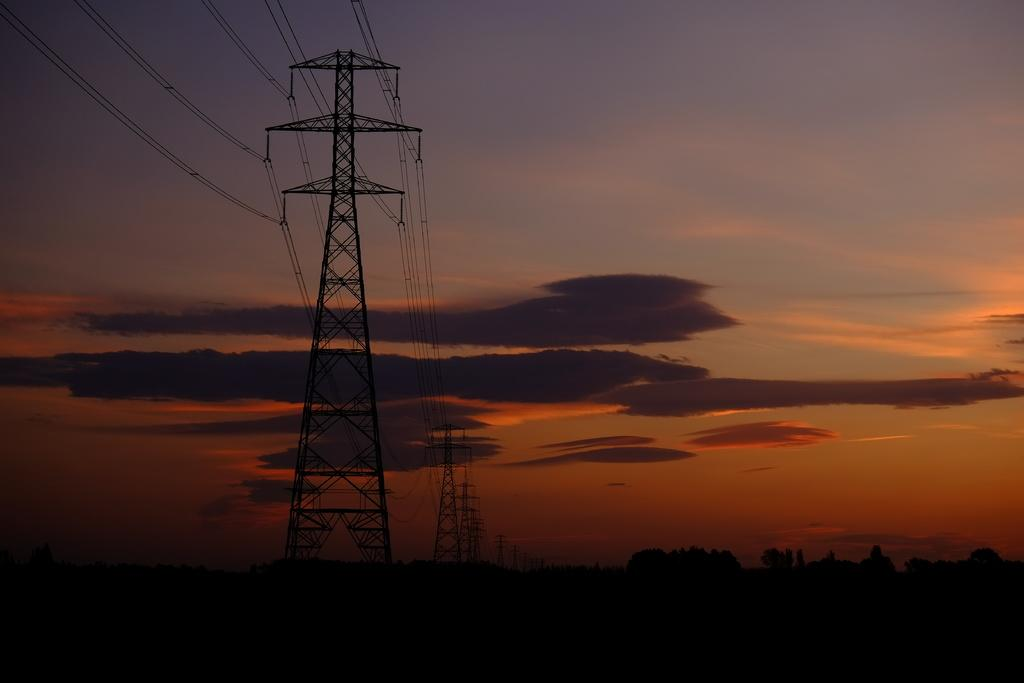What structures are present in the image with wires attached to them? There are towers with wires in the image. What type of vegetation can be seen in the image? There is a group of trees in the image. What is the condition of the sky in the image? The sky is visible and appears cloudy in the image. What type of quartz can be seen in the image? There is no quartz present in the image. What kind of camera is being used to take the picture? The facts provided do not mention any camera being used to take the picture, so we cannot determine the type of camera. 